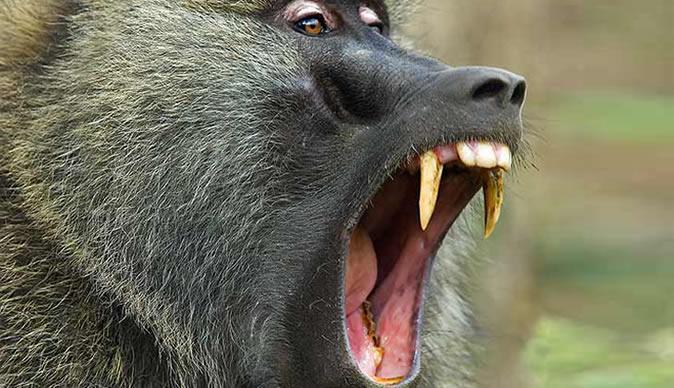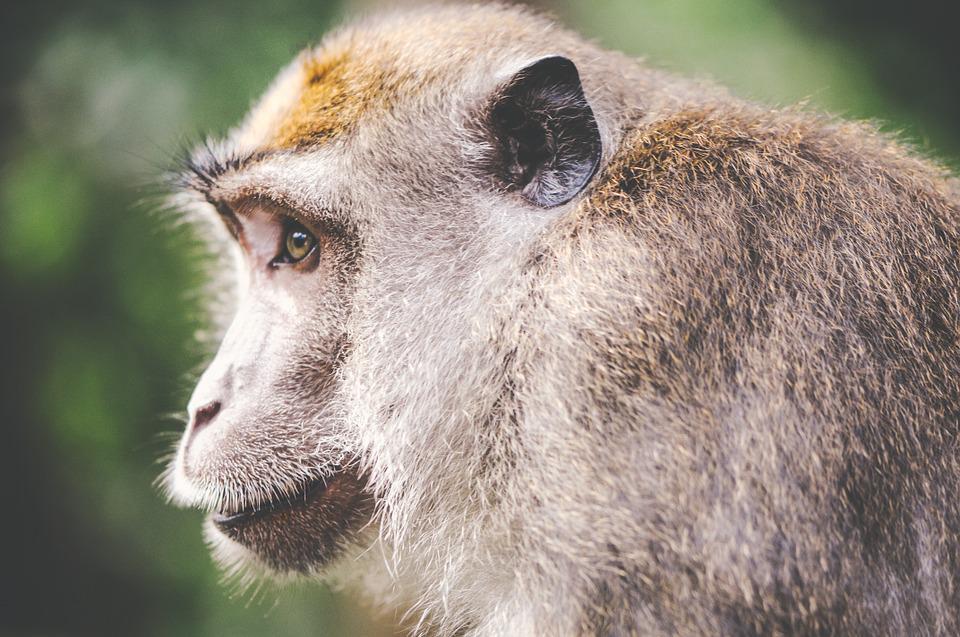The first image is the image on the left, the second image is the image on the right. Assess this claim about the two images: "Each image contains exactly one monkey, and the monkeys on the right and left are the same approximate age [mature or immature].". Correct or not? Answer yes or no. Yes. The first image is the image on the left, the second image is the image on the right. Examine the images to the left and right. Is the description "There is text in both images." accurate? Answer yes or no. No. 